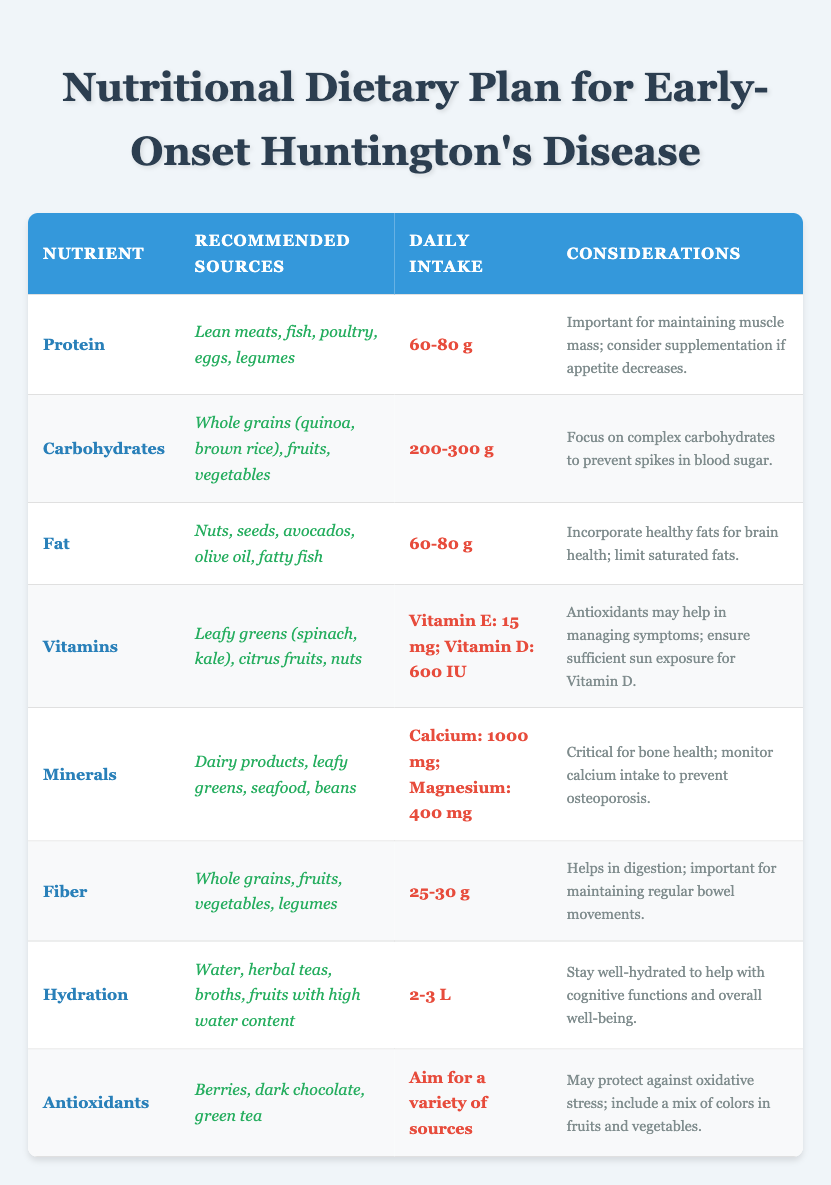What is the recommended daily intake for protein? The table lists the daily intake for protein as "60-80 g".
Answer: 60-80 g Which nutrient has the highest daily intake recommendation? By reviewing the daily intake recommendations, carbohydrates and vitamins each have their recommendations stated more broadly, but if we consider specific nutrients, Calcium at 1000 mg is the highest daily intake recommended.
Answer: Calcium: 1000 mg True or False: Antioxidants should only come from dark chocolate. The table states that antioxidants can be sourced from "berries, dark chocolate, and green tea", indicating multiple sources are recommended.
Answer: False What is the total recommended daily intake for Calcium and Magnesium? From the table, Calcium is 1000 mg and Magnesium is 400 mg. The total is calculated as 1000 + 400 = 1400 mg.
Answer: 1400 mg Which nutrient's recommended daily intake is specifically noted to require an average intake of a range? The nutrient that has a range of values specified is Protein, with a recommended intake of "60-80 g".
Answer: Protein For hydration, how many liters are recommended daily? The daily intake for hydration is specified as "2-3 L".
Answer: 2-3 L What considerations should be taken into account for vitamin intake? The table states that "antioxidants may help in managing symptoms; ensure sufficient sun exposure for Vitamin D", summarizing the key considerations related to vitamin intake.
Answer: Ensure sufficient sun exposure for Vitamin D Which nutrient involves maintaining muscle mass as a consideration? The consideration for protein states that it is important for "maintaining muscle mass" and suggests supplementation if appetite decreases.
Answer: Protein If you combine the daily intake ranges for fat and protein, what do you get? The daily intake for fat is 60-80 g, and for protein, it is also 60-80 g. The range is combined as follows: Minimum intake = 60 + 60 = 120 g, Maximum intake = 80 + 80 = 160 g, so the combined range is 120-160 g.
Answer: 120-160 g What is one food recommendation for improving brain health? The table mentions that incorporating "healthy fats" is beneficial for brain health, citing examples like avocados and fatty fish.
Answer: Healthy fats (e.g., avocados, fatty fish) Is the intake of Fiber important for digestion? The table explicitly states that fiber "helps in digestion; important for maintaining regular bowel movements," affirming its importance for digestive health.
Answer: Yes 